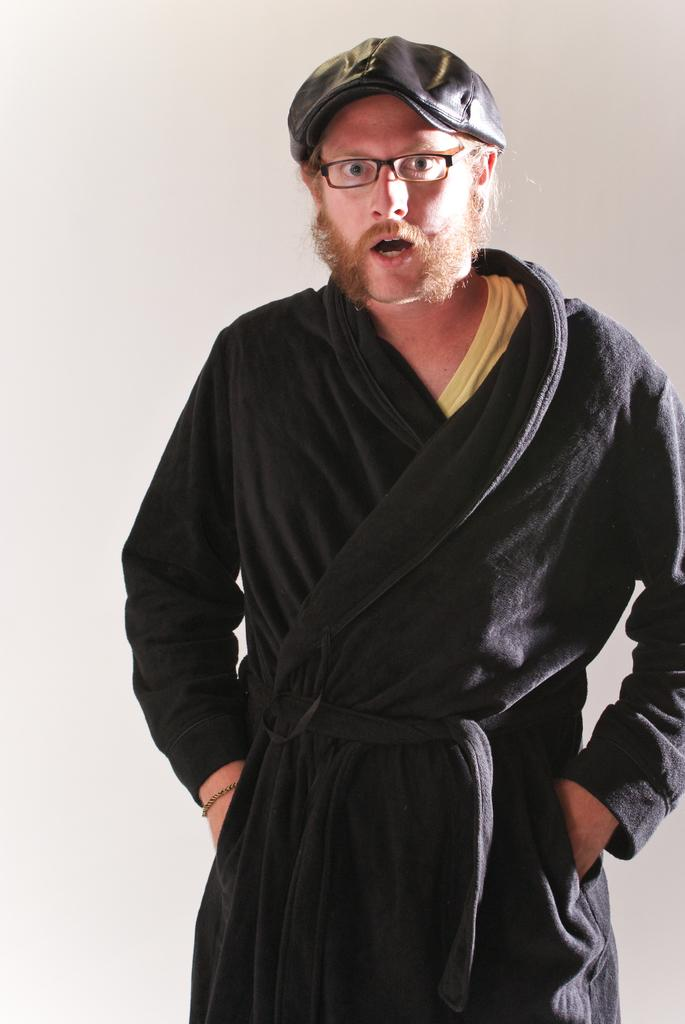What is the main subject of the image? There is a person standing in the image. What is the person wearing? The person is wearing a black dress. What color is the background of the image? The background of the image is white. How many stamps are on the person's lip in the image? There are no stamps or lips visible in the image; it only features a person standing in a black dress against a white background. 